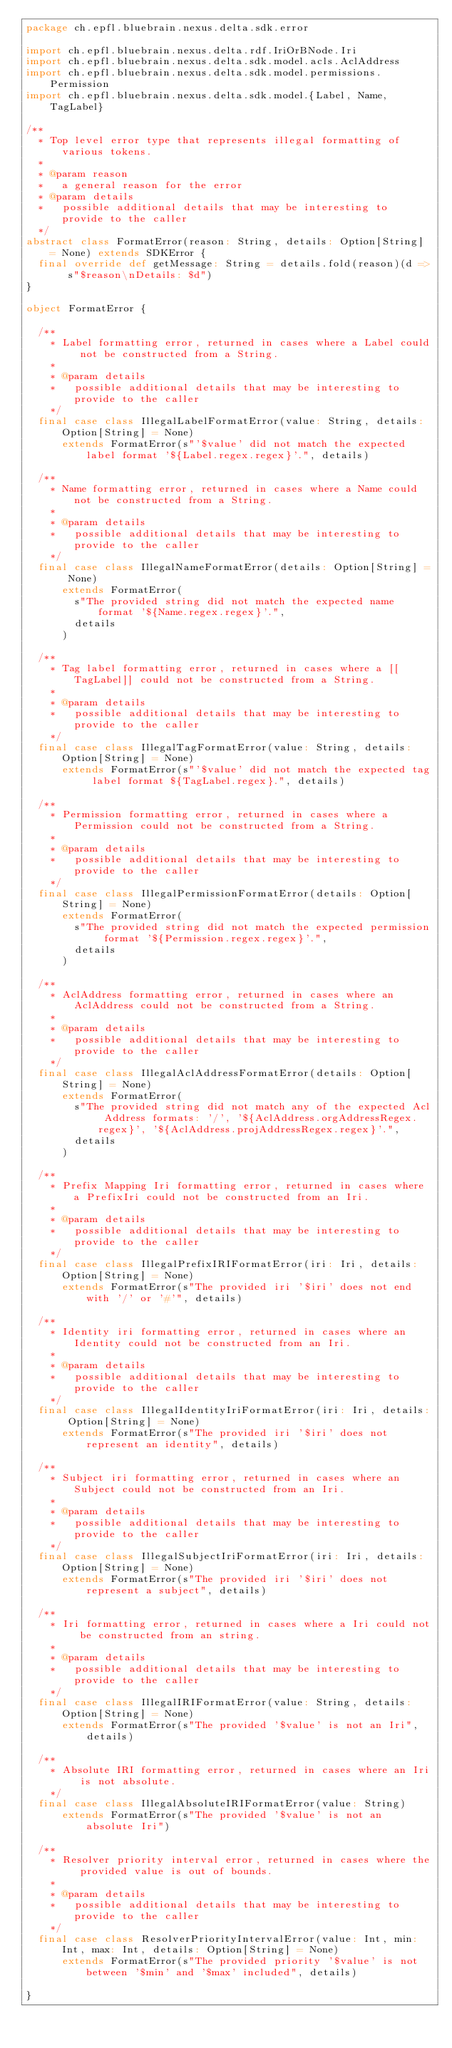Convert code to text. <code><loc_0><loc_0><loc_500><loc_500><_Scala_>package ch.epfl.bluebrain.nexus.delta.sdk.error

import ch.epfl.bluebrain.nexus.delta.rdf.IriOrBNode.Iri
import ch.epfl.bluebrain.nexus.delta.sdk.model.acls.AclAddress
import ch.epfl.bluebrain.nexus.delta.sdk.model.permissions.Permission
import ch.epfl.bluebrain.nexus.delta.sdk.model.{Label, Name, TagLabel}

/**
  * Top level error type that represents illegal formatting of various tokens.
  *
  * @param reason
  *   a general reason for the error
  * @param details
  *   possible additional details that may be interesting to provide to the caller
  */
abstract class FormatError(reason: String, details: Option[String] = None) extends SDKError {
  final override def getMessage: String = details.fold(reason)(d => s"$reason\nDetails: $d")
}

object FormatError {

  /**
    * Label formatting error, returned in cases where a Label could not be constructed from a String.
    *
    * @param details
    *   possible additional details that may be interesting to provide to the caller
    */
  final case class IllegalLabelFormatError(value: String, details: Option[String] = None)
      extends FormatError(s"'$value' did not match the expected label format '${Label.regex.regex}'.", details)

  /**
    * Name formatting error, returned in cases where a Name could not be constructed from a String.
    *
    * @param details
    *   possible additional details that may be interesting to provide to the caller
    */
  final case class IllegalNameFormatError(details: Option[String] = None)
      extends FormatError(
        s"The provided string did not match the expected name format '${Name.regex.regex}'.",
        details
      )

  /**
    * Tag label formatting error, returned in cases where a [[TagLabel]] could not be constructed from a String.
    *
    * @param details
    *   possible additional details that may be interesting to provide to the caller
    */
  final case class IllegalTagFormatError(value: String, details: Option[String] = None)
      extends FormatError(s"'$value' did not match the expected tag label format ${TagLabel.regex}.", details)

  /**
    * Permission formatting error, returned in cases where a Permission could not be constructed from a String.
    *
    * @param details
    *   possible additional details that may be interesting to provide to the caller
    */
  final case class IllegalPermissionFormatError(details: Option[String] = None)
      extends FormatError(
        s"The provided string did not match the expected permission format '${Permission.regex.regex}'.",
        details
      )

  /**
    * AclAddress formatting error, returned in cases where an AclAddress could not be constructed from a String.
    *
    * @param details
    *   possible additional details that may be interesting to provide to the caller
    */
  final case class IllegalAclAddressFormatError(details: Option[String] = None)
      extends FormatError(
        s"The provided string did not match any of the expected Acl Address formats: '/', '${AclAddress.orgAddressRegex.regex}', '${AclAddress.projAddressRegex.regex}'.",
        details
      )

  /**
    * Prefix Mapping Iri formatting error, returned in cases where a PrefixIri could not be constructed from an Iri.
    *
    * @param details
    *   possible additional details that may be interesting to provide to the caller
    */
  final case class IllegalPrefixIRIFormatError(iri: Iri, details: Option[String] = None)
      extends FormatError(s"The provided iri '$iri' does not end with '/' or '#'", details)

  /**
    * Identity iri formatting error, returned in cases where an Identity could not be constructed from an Iri.
    *
    * @param details
    *   possible additional details that may be interesting to provide to the caller
    */
  final case class IllegalIdentityIriFormatError(iri: Iri, details: Option[String] = None)
      extends FormatError(s"The provided iri '$iri' does not represent an identity", details)

  /**
    * Subject iri formatting error, returned in cases where an Subject could not be constructed from an Iri.
    *
    * @param details
    *   possible additional details that may be interesting to provide to the caller
    */
  final case class IllegalSubjectIriFormatError(iri: Iri, details: Option[String] = None)
      extends FormatError(s"The provided iri '$iri' does not represent a subject", details)

  /**
    * Iri formatting error, returned in cases where a Iri could not be constructed from an string.
    *
    * @param details
    *   possible additional details that may be interesting to provide to the caller
    */
  final case class IllegalIRIFormatError(value: String, details: Option[String] = None)
      extends FormatError(s"The provided '$value' is not an Iri", details)

  /**
    * Absolute IRI formatting error, returned in cases where an Iri is not absolute.
    */
  final case class IllegalAbsoluteIRIFormatError(value: String)
      extends FormatError(s"The provided '$value' is not an absolute Iri")

  /**
    * Resolver priority interval error, returned in cases where the provided value is out of bounds.
    *
    * @param details
    *   possible additional details that may be interesting to provide to the caller
    */
  final case class ResolverPriorityIntervalError(value: Int, min: Int, max: Int, details: Option[String] = None)
      extends FormatError(s"The provided priority '$value' is not between '$min' and '$max' included", details)

}
</code> 